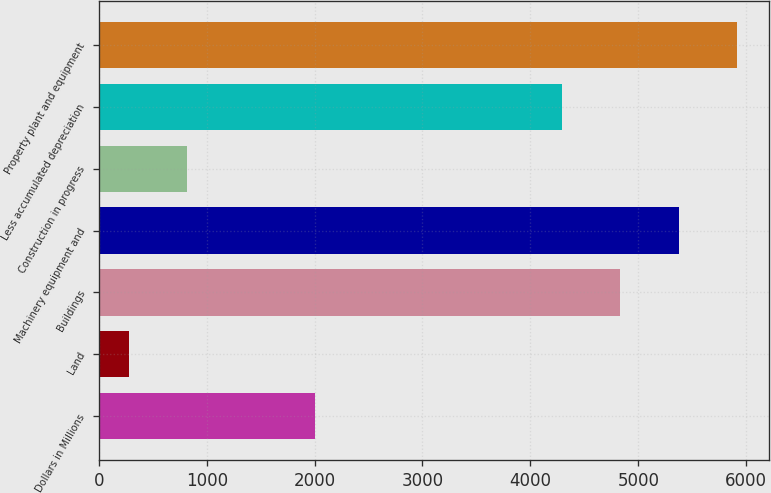Convert chart to OTSL. <chart><loc_0><loc_0><loc_500><loc_500><bar_chart><fcel>Dollars in Millions<fcel>Land<fcel>Buildings<fcel>Machinery equipment and<fcel>Construction in progress<fcel>Less accumulated depreciation<fcel>Property plant and equipment<nl><fcel>2005<fcel>280<fcel>4832.3<fcel>5373.6<fcel>821.3<fcel>4291<fcel>5914.9<nl></chart> 